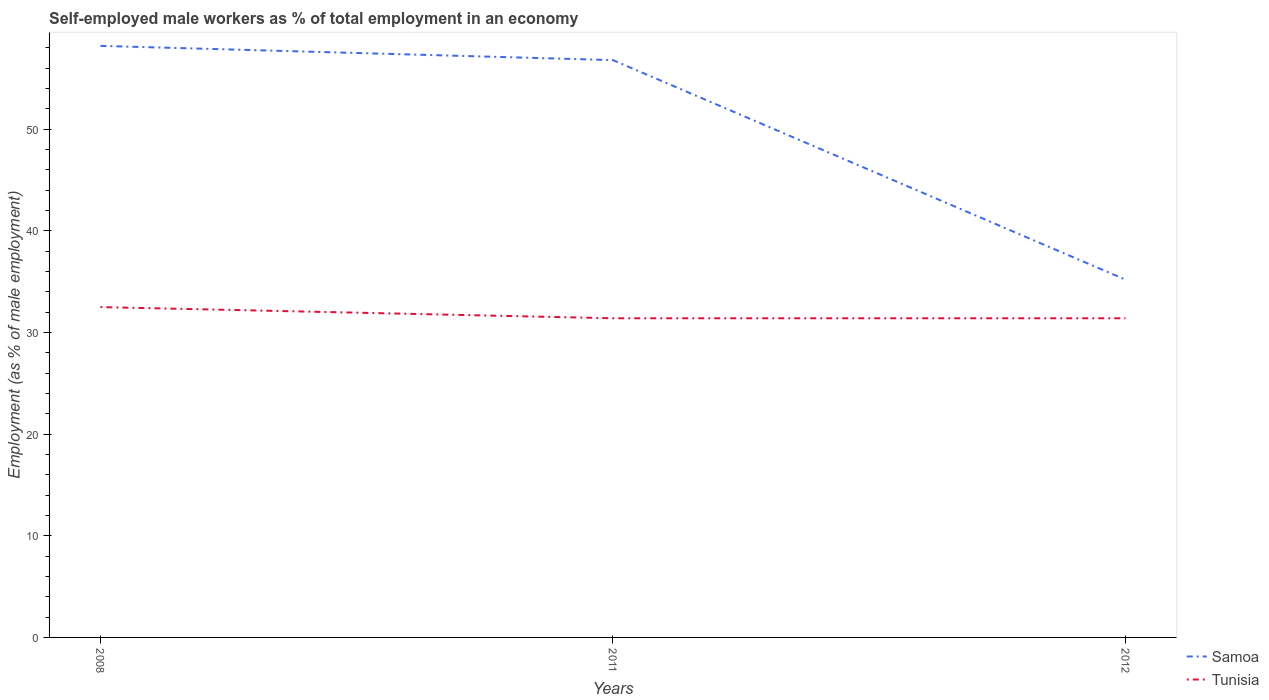How many different coloured lines are there?
Make the answer very short. 2. Does the line corresponding to Tunisia intersect with the line corresponding to Samoa?
Provide a succinct answer. No. Is the number of lines equal to the number of legend labels?
Provide a short and direct response. Yes. Across all years, what is the maximum percentage of self-employed male workers in Tunisia?
Provide a succinct answer. 31.4. In which year was the percentage of self-employed male workers in Samoa maximum?
Your response must be concise. 2012. What is the total percentage of self-employed male workers in Tunisia in the graph?
Ensure brevity in your answer.  1.1. What is the difference between the highest and the second highest percentage of self-employed male workers in Samoa?
Give a very brief answer. 23. How many lines are there?
Keep it short and to the point. 2. What is the difference between two consecutive major ticks on the Y-axis?
Give a very brief answer. 10. Where does the legend appear in the graph?
Your answer should be very brief. Bottom right. How are the legend labels stacked?
Your answer should be compact. Vertical. What is the title of the graph?
Give a very brief answer. Self-employed male workers as % of total employment in an economy. What is the label or title of the Y-axis?
Ensure brevity in your answer.  Employment (as % of male employment). What is the Employment (as % of male employment) of Samoa in 2008?
Give a very brief answer. 58.2. What is the Employment (as % of male employment) in Tunisia in 2008?
Your answer should be compact. 32.5. What is the Employment (as % of male employment) in Samoa in 2011?
Your answer should be compact. 56.8. What is the Employment (as % of male employment) of Tunisia in 2011?
Provide a succinct answer. 31.4. What is the Employment (as % of male employment) in Samoa in 2012?
Your response must be concise. 35.2. What is the Employment (as % of male employment) in Tunisia in 2012?
Give a very brief answer. 31.4. Across all years, what is the maximum Employment (as % of male employment) in Samoa?
Give a very brief answer. 58.2. Across all years, what is the maximum Employment (as % of male employment) in Tunisia?
Offer a very short reply. 32.5. Across all years, what is the minimum Employment (as % of male employment) of Samoa?
Give a very brief answer. 35.2. Across all years, what is the minimum Employment (as % of male employment) of Tunisia?
Your answer should be compact. 31.4. What is the total Employment (as % of male employment) in Samoa in the graph?
Ensure brevity in your answer.  150.2. What is the total Employment (as % of male employment) of Tunisia in the graph?
Make the answer very short. 95.3. What is the difference between the Employment (as % of male employment) of Samoa in 2008 and that in 2011?
Offer a terse response. 1.4. What is the difference between the Employment (as % of male employment) of Tunisia in 2008 and that in 2011?
Your answer should be compact. 1.1. What is the difference between the Employment (as % of male employment) in Samoa in 2008 and that in 2012?
Your answer should be very brief. 23. What is the difference between the Employment (as % of male employment) in Tunisia in 2008 and that in 2012?
Make the answer very short. 1.1. What is the difference between the Employment (as % of male employment) of Samoa in 2011 and that in 2012?
Provide a succinct answer. 21.6. What is the difference between the Employment (as % of male employment) of Tunisia in 2011 and that in 2012?
Provide a succinct answer. 0. What is the difference between the Employment (as % of male employment) in Samoa in 2008 and the Employment (as % of male employment) in Tunisia in 2011?
Make the answer very short. 26.8. What is the difference between the Employment (as % of male employment) in Samoa in 2008 and the Employment (as % of male employment) in Tunisia in 2012?
Provide a succinct answer. 26.8. What is the difference between the Employment (as % of male employment) in Samoa in 2011 and the Employment (as % of male employment) in Tunisia in 2012?
Your answer should be compact. 25.4. What is the average Employment (as % of male employment) in Samoa per year?
Offer a very short reply. 50.07. What is the average Employment (as % of male employment) in Tunisia per year?
Make the answer very short. 31.77. In the year 2008, what is the difference between the Employment (as % of male employment) in Samoa and Employment (as % of male employment) in Tunisia?
Offer a very short reply. 25.7. In the year 2011, what is the difference between the Employment (as % of male employment) of Samoa and Employment (as % of male employment) of Tunisia?
Ensure brevity in your answer.  25.4. In the year 2012, what is the difference between the Employment (as % of male employment) of Samoa and Employment (as % of male employment) of Tunisia?
Keep it short and to the point. 3.8. What is the ratio of the Employment (as % of male employment) in Samoa in 2008 to that in 2011?
Provide a short and direct response. 1.02. What is the ratio of the Employment (as % of male employment) of Tunisia in 2008 to that in 2011?
Offer a very short reply. 1.03. What is the ratio of the Employment (as % of male employment) in Samoa in 2008 to that in 2012?
Give a very brief answer. 1.65. What is the ratio of the Employment (as % of male employment) of Tunisia in 2008 to that in 2012?
Give a very brief answer. 1.03. What is the ratio of the Employment (as % of male employment) in Samoa in 2011 to that in 2012?
Offer a very short reply. 1.61. What is the ratio of the Employment (as % of male employment) of Tunisia in 2011 to that in 2012?
Offer a terse response. 1. What is the difference between the highest and the second highest Employment (as % of male employment) of Samoa?
Give a very brief answer. 1.4. What is the difference between the highest and the lowest Employment (as % of male employment) of Samoa?
Your answer should be compact. 23. What is the difference between the highest and the lowest Employment (as % of male employment) in Tunisia?
Keep it short and to the point. 1.1. 